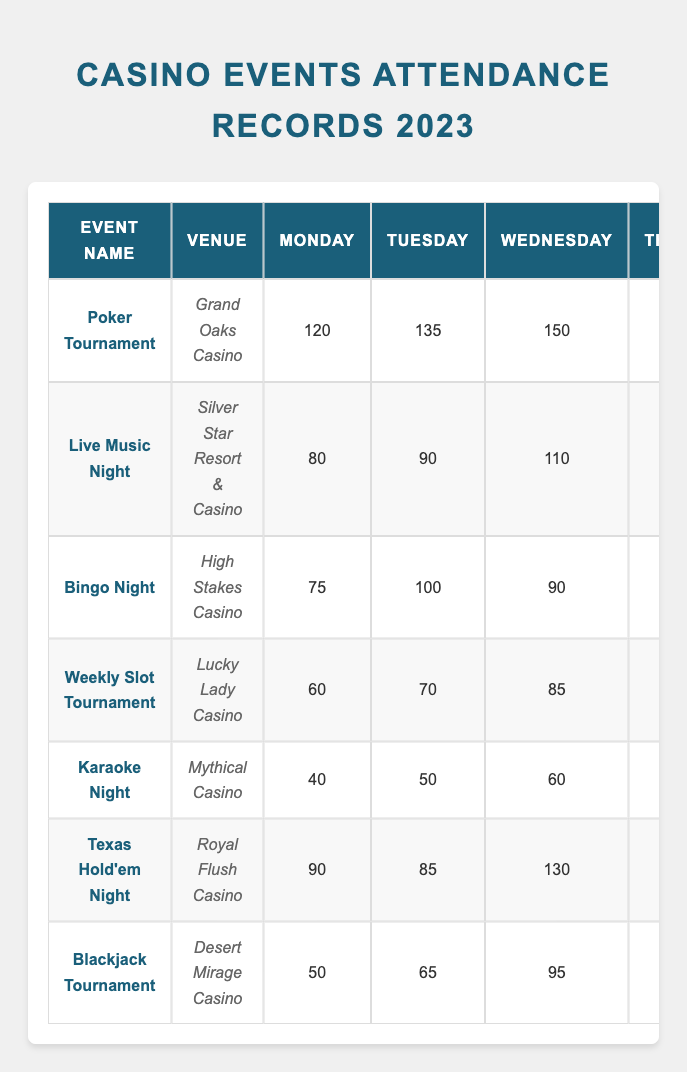What is the total attendance for the "Poker Tournament" on Saturday? The table indicates that the "Poker Tournament" at Grand Oaks Casino had an attendance of 300 on Saturday. Since this is a single data point, the total attendance is simply that number.
Answer: 300 What day had the highest attendance for the "Texas Hold'em Night"? Looking at the "Texas Hold'em Night" row, the attendance numbers are 90 (Monday), 85 (Tuesday), 130 (Wednesday), 140 (Thursday), 220 (Friday), 310 (Saturday), and 170 (Sunday). The highest attendance is 310 on Saturday.
Answer: Saturday What was the average attendance for the "Karaoke Night" over the week? To find the average attendance, we sum the attendances for each day: 40 + 50 + 60 + 70 + 100 + 180 + 110 = 610. There are 7 days, so the average is 610 ÷ 7 ≈ 87.14.
Answer: 87.14 Is there a day when the "Bingo Night" had more than 200 attendees? Referring to the "Bingo Night" row, the attendance numbers are 75 (Monday), 100 (Tuesday), 90 (Wednesday), 110 (Thursday), 150 (Friday), 225 (Saturday), and 160 (Sunday). There is one day, Saturday, when attendance exceeded 200.
Answer: Yes What is the difference in attendance between "Live Music Night" and "Weekly Slot Tournament" on Friday? For "Live Music Night," attendance on Friday is 200, and for "Weekly Slot Tournament," it is 130. The difference is calculated by subtracting the smaller from the larger: 200 - 130 = 70.
Answer: 70 Which event had the lowest total attendance over the week? We sum the attendance for each event. "Karaoke Night": 40 + 50 + 60 + 70 + 100 + 180 + 110 = 610. "Weekly Slot Tournament": 60 + 70 + 85 + 95 + 130 + 200 + 140 = 780. "Blackjack Tournament": 50 + 65 + 95 + 90 + 130 + 190 + 140 = 960. "Bingo Night": 75 + 100 + 90 + 110 + 150 + 225 + 160 = 1010. "Texas Hold'em Night": 90 + 85 + 130 + 140 + 220 + 310 + 170 = 1145. "Live Music Night": 80 + 90 + 110 + 120 + 200 + 250 + 150 = 1100. "Poker Tournament": 120 + 135 + 150 + 160 + 250 + 300 + 180 = 1295. The event with the lowest total attendance is "Karaoke Night" with 610.
Answer: Karaoke Night What was the total attendance for all events on Sunday? We sum the Sunday attendance of each event: 180 (Poker Tournament) + 150 (Live Music Night) + 160 (Bingo Night) + 140 (Weekly Slot Tournament) + 110 (Karaoke Night) + 170 (Texas Hold'em Night) + 140 (Blackjack Tournament) = 1,050.
Answer: 1050 On which day did the "Blackjack Tournament" have more attendees, Saturday or Sunday? "Blackjack Tournament" attendance on Saturday is 190 and on Sunday is 140. Comparing these values, 190 is greater than 140, indicating Saturday as the day with more attendees.
Answer: Saturday 